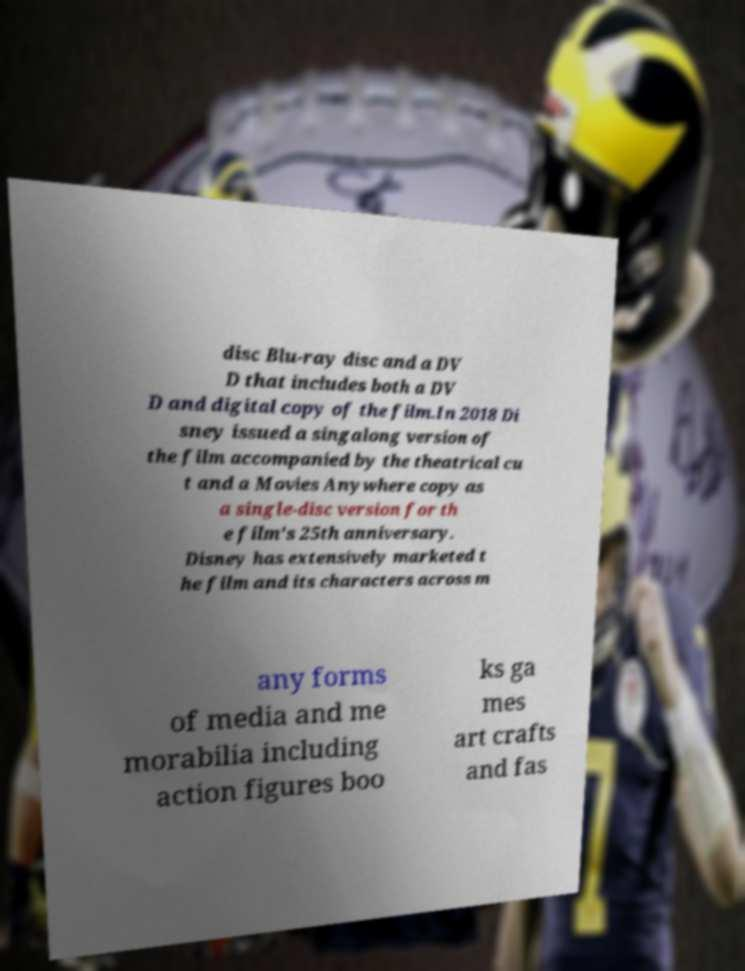For documentation purposes, I need the text within this image transcribed. Could you provide that? disc Blu-ray disc and a DV D that includes both a DV D and digital copy of the film.In 2018 Di sney issued a singalong version of the film accompanied by the theatrical cu t and a Movies Anywhere copy as a single-disc version for th e film's 25th anniversary. Disney has extensively marketed t he film and its characters across m any forms of media and me morabilia including action figures boo ks ga mes art crafts and fas 